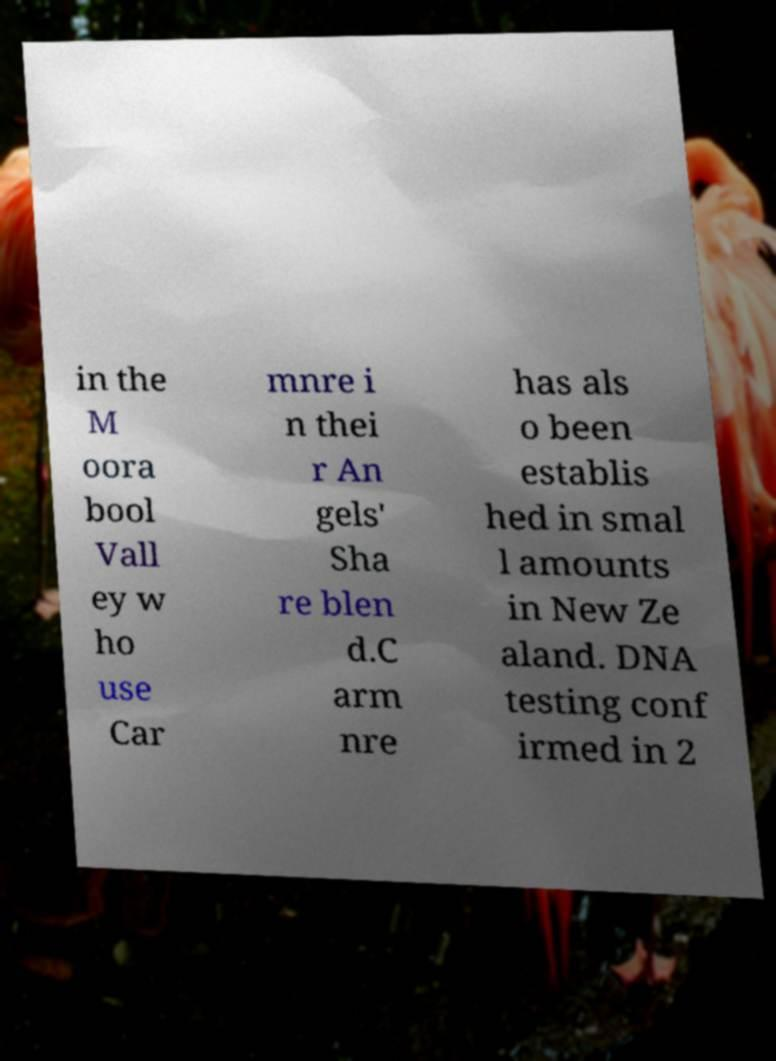I need the written content from this picture converted into text. Can you do that? in the M oora bool Vall ey w ho use Car mnre i n thei r An gels' Sha re blen d.C arm nre has als o been establis hed in smal l amounts in New Ze aland. DNA testing conf irmed in 2 